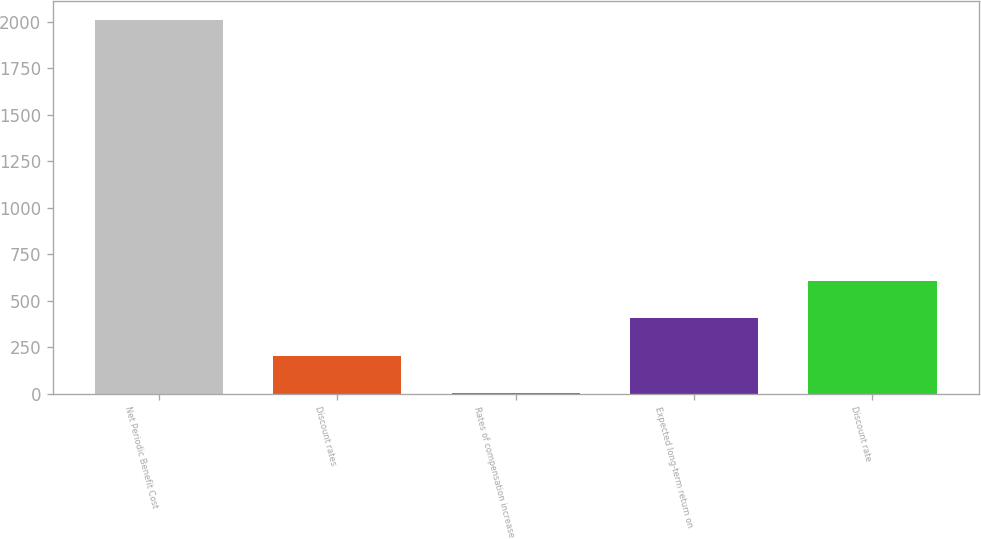Convert chart. <chart><loc_0><loc_0><loc_500><loc_500><bar_chart><fcel>Net Periodic Benefit Cost<fcel>Discount rates<fcel>Rates of compensation increase<fcel>Expected long-term return on<fcel>Discount rate<nl><fcel>2011<fcel>203.3<fcel>2.44<fcel>404.16<fcel>605.02<nl></chart> 